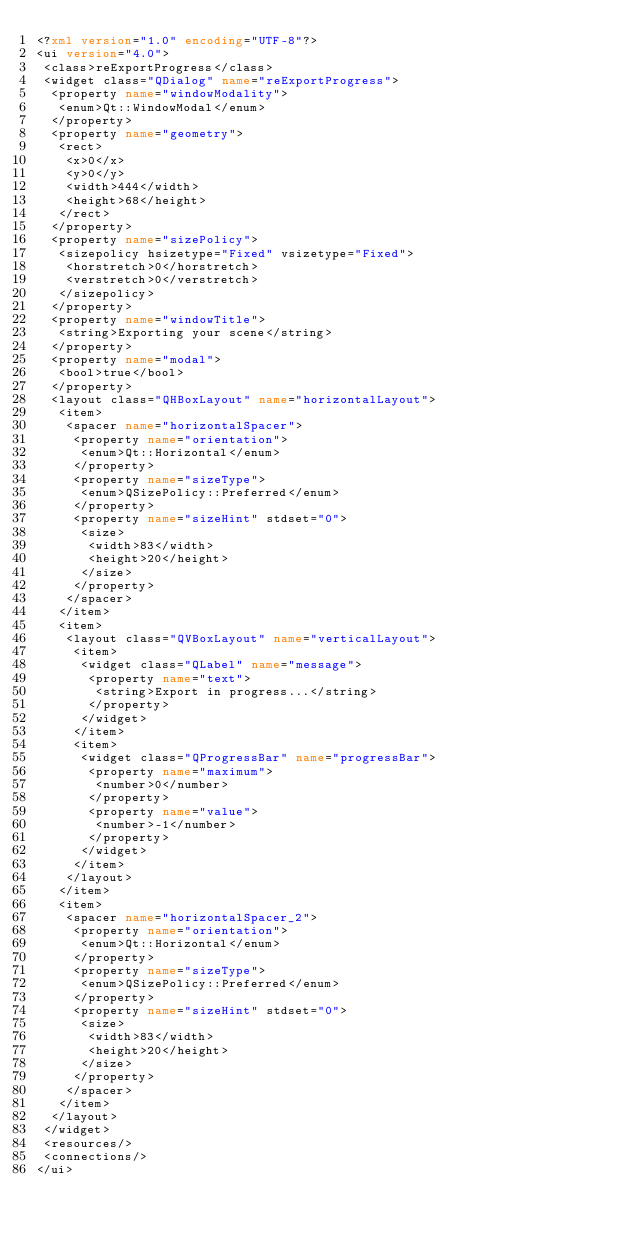Convert code to text. <code><loc_0><loc_0><loc_500><loc_500><_XML_><?xml version="1.0" encoding="UTF-8"?>
<ui version="4.0">
 <class>reExportProgress</class>
 <widget class="QDialog" name="reExportProgress">
  <property name="windowModality">
   <enum>Qt::WindowModal</enum>
  </property>
  <property name="geometry">
   <rect>
    <x>0</x>
    <y>0</y>
    <width>444</width>
    <height>68</height>
   </rect>
  </property>
  <property name="sizePolicy">
   <sizepolicy hsizetype="Fixed" vsizetype="Fixed">
    <horstretch>0</horstretch>
    <verstretch>0</verstretch>
   </sizepolicy>
  </property>
  <property name="windowTitle">
   <string>Exporting your scene</string>
  </property>
  <property name="modal">
   <bool>true</bool>
  </property>
  <layout class="QHBoxLayout" name="horizontalLayout">
   <item>
    <spacer name="horizontalSpacer">
     <property name="orientation">
      <enum>Qt::Horizontal</enum>
     </property>
     <property name="sizeType">
      <enum>QSizePolicy::Preferred</enum>
     </property>
     <property name="sizeHint" stdset="0">
      <size>
       <width>83</width>
       <height>20</height>
      </size>
     </property>
    </spacer>
   </item>
   <item>
    <layout class="QVBoxLayout" name="verticalLayout">
     <item>
      <widget class="QLabel" name="message">
       <property name="text">
        <string>Export in progress...</string>
       </property>
      </widget>
     </item>
     <item>
      <widget class="QProgressBar" name="progressBar">
       <property name="maximum">
        <number>0</number>
       </property>
       <property name="value">
        <number>-1</number>
       </property>
      </widget>
     </item>
    </layout>
   </item>
   <item>
    <spacer name="horizontalSpacer_2">
     <property name="orientation">
      <enum>Qt::Horizontal</enum>
     </property>
     <property name="sizeType">
      <enum>QSizePolicy::Preferred</enum>
     </property>
     <property name="sizeHint" stdset="0">
      <size>
       <width>83</width>
       <height>20</height>
      </size>
     </property>
    </spacer>
   </item>
  </layout>
 </widget>
 <resources/>
 <connections/>
</ui>
</code> 